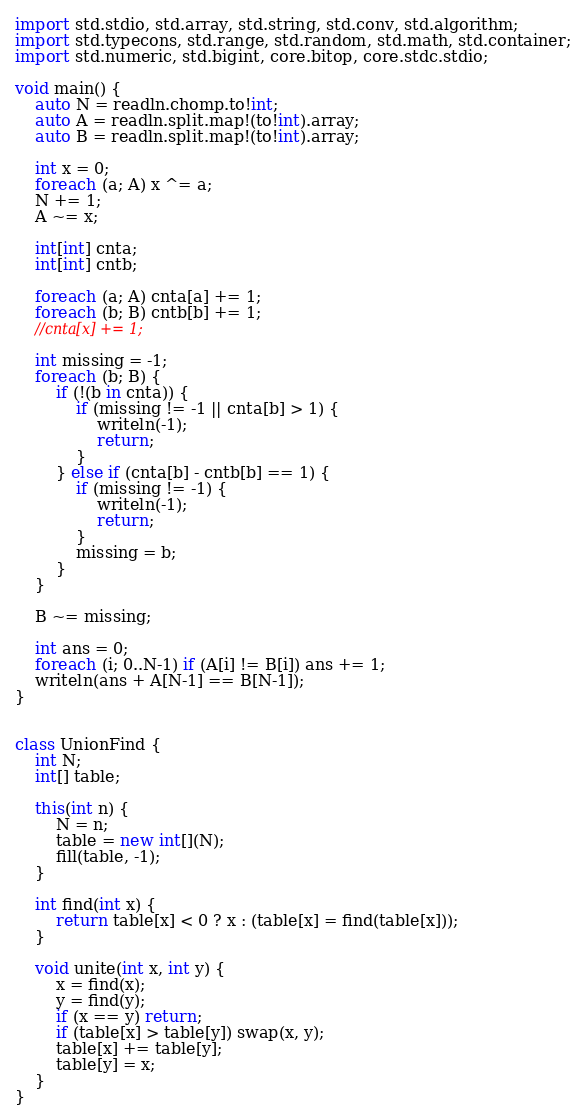Convert code to text. <code><loc_0><loc_0><loc_500><loc_500><_D_>import std.stdio, std.array, std.string, std.conv, std.algorithm;
import std.typecons, std.range, std.random, std.math, std.container;
import std.numeric, std.bigint, core.bitop, core.stdc.stdio;

void main() {
    auto N = readln.chomp.to!int;
    auto A = readln.split.map!(to!int).array;
    auto B = readln.split.map!(to!int).array;

    int x = 0;
    foreach (a; A) x ^= a;
    N += 1;
    A ~= x;

    int[int] cnta;
    int[int] cntb;

    foreach (a; A) cnta[a] += 1;
    foreach (b; B) cntb[b] += 1;
    //cnta[x] += 1;

    int missing = -1;
    foreach (b; B) {
        if (!(b in cnta)) {
            if (missing != -1 || cnta[b] > 1) {
                writeln(-1);
                return;
            }
        } else if (cnta[b] - cntb[b] == 1) {
            if (missing != -1) {
                writeln(-1);
                return;
            }
            missing = b;
        }
    }

    B ~= missing;

    int ans = 0;
    foreach (i; 0..N-1) if (A[i] != B[i]) ans += 1;
    writeln(ans + A[N-1] == B[N-1]);
}


class UnionFind {
    int N;
    int[] table;

    this(int n) {
        N = n;
        table = new int[](N);
        fill(table, -1);
    }

    int find(int x) {
        return table[x] < 0 ? x : (table[x] = find(table[x]));
    }

    void unite(int x, int y) {
        x = find(x);
        y = find(y);
        if (x == y) return;
        if (table[x] > table[y]) swap(x, y);
        table[x] += table[y];
        table[y] = x;
    }
}
</code> 